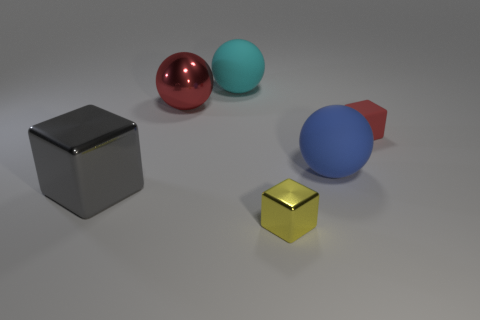Can you describe the colors of the objects in more detail? Certainly! The image depicts a collection of geometric objects with different colors and finishes. Starting from the left, there's a shiny, reflective black cube. Next, we have a glossy crimson sphere along with a matte turquoise sphere. The larger object in the background is a cobalt blue sphere, partially obscured by a matte red cone. Finally, there is a small, shiny metallic-gold cube in the foreground. 